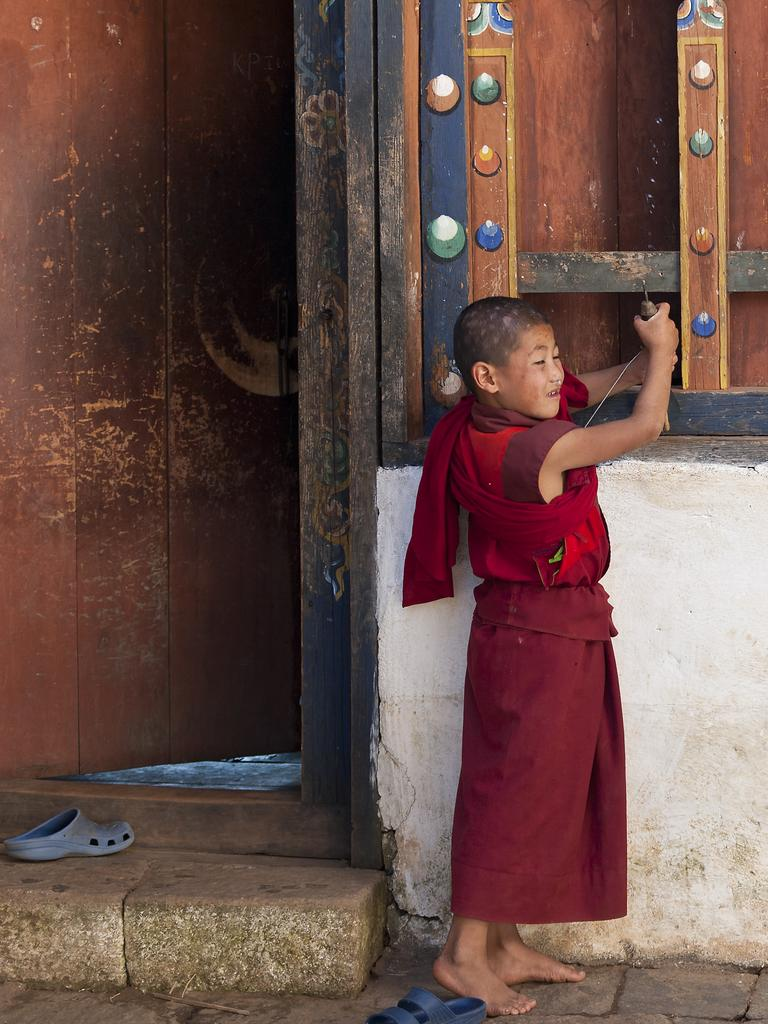What is the main subject of the image? There is a boy standing in the image. What can be seen in the background of the image? There is a window in the image. Are there any architectural features visible in the image? Yes, there is a door in the image. What type of footwear is present on the ground in the image? There are slippers on the ground in the image. Can you hear the owl hooting in the image? There is no owl present in the image, so it cannot be heard hooting. 